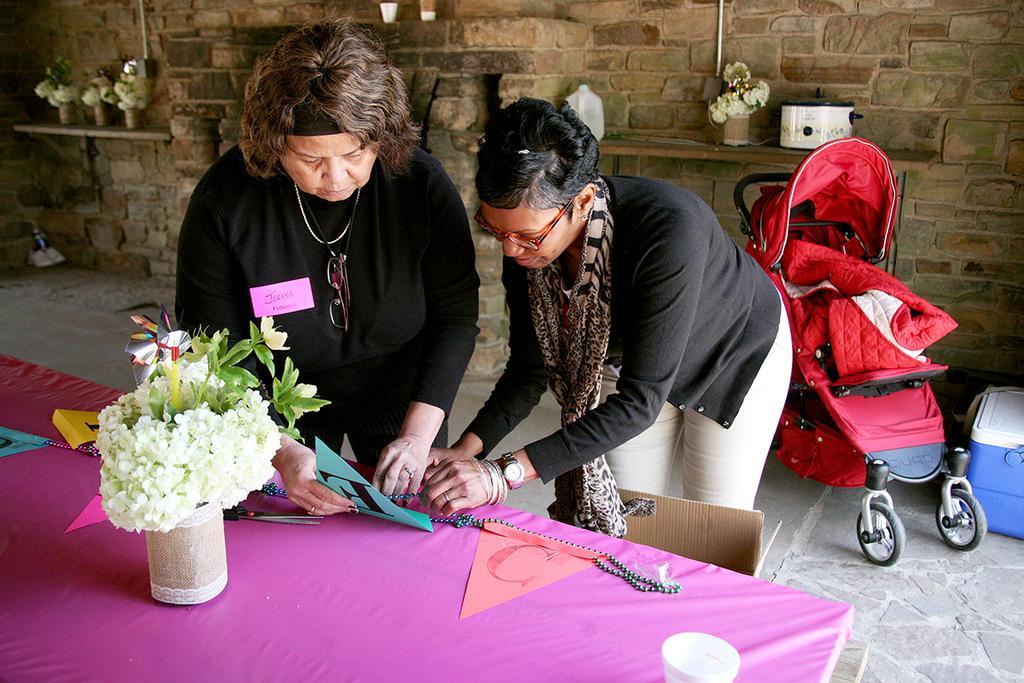Please provide a concise description of this image. Here we can see two women and they are holding a paper. And there are pearls. This is a baby stroller. Here we can see a table, flower vases, cup, box, and a bottle. This is floor. In the background there is a wall. 